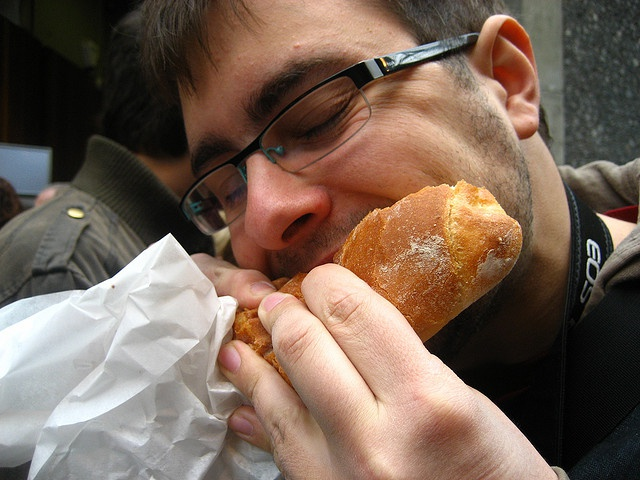Describe the objects in this image and their specific colors. I can see people in black, gray, tan, and maroon tones, people in black, gray, and maroon tones, and sandwich in black, brown, tan, maroon, and salmon tones in this image. 